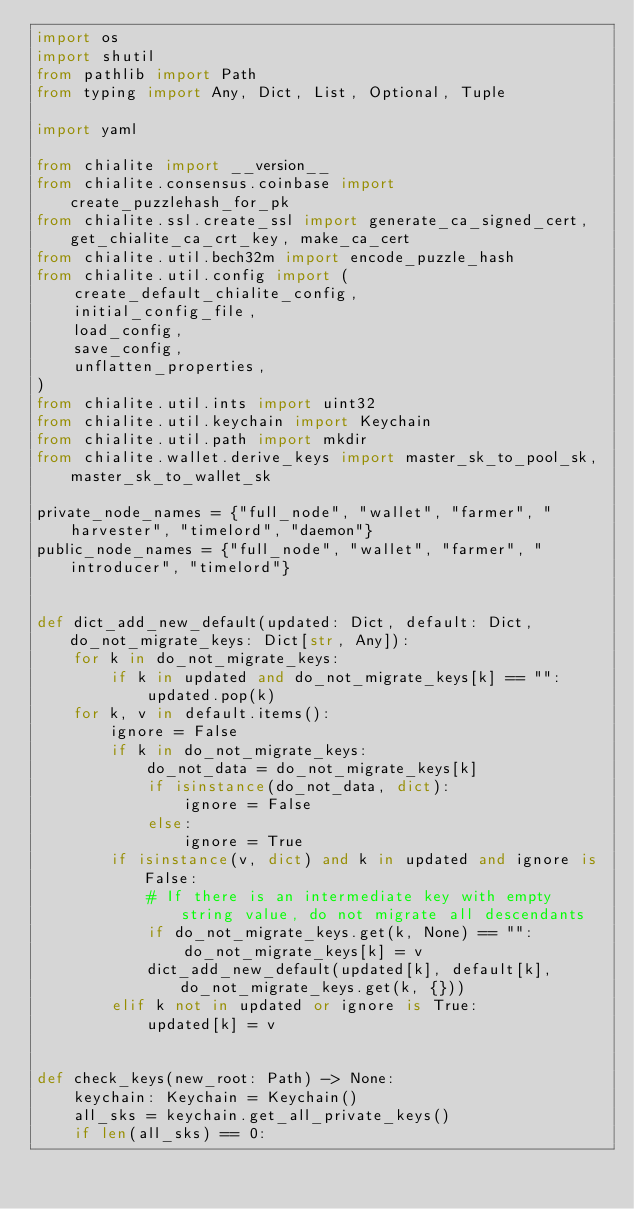<code> <loc_0><loc_0><loc_500><loc_500><_Python_>import os
import shutil
from pathlib import Path
from typing import Any, Dict, List, Optional, Tuple

import yaml

from chialite import __version__
from chialite.consensus.coinbase import create_puzzlehash_for_pk
from chialite.ssl.create_ssl import generate_ca_signed_cert, get_chialite_ca_crt_key, make_ca_cert
from chialite.util.bech32m import encode_puzzle_hash
from chialite.util.config import (
    create_default_chialite_config,
    initial_config_file,
    load_config,
    save_config,
    unflatten_properties,
)
from chialite.util.ints import uint32
from chialite.util.keychain import Keychain
from chialite.util.path import mkdir
from chialite.wallet.derive_keys import master_sk_to_pool_sk, master_sk_to_wallet_sk

private_node_names = {"full_node", "wallet", "farmer", "harvester", "timelord", "daemon"}
public_node_names = {"full_node", "wallet", "farmer", "introducer", "timelord"}


def dict_add_new_default(updated: Dict, default: Dict, do_not_migrate_keys: Dict[str, Any]):
    for k in do_not_migrate_keys:
        if k in updated and do_not_migrate_keys[k] == "":
            updated.pop(k)
    for k, v in default.items():
        ignore = False
        if k in do_not_migrate_keys:
            do_not_data = do_not_migrate_keys[k]
            if isinstance(do_not_data, dict):
                ignore = False
            else:
                ignore = True
        if isinstance(v, dict) and k in updated and ignore is False:
            # If there is an intermediate key with empty string value, do not migrate all descendants
            if do_not_migrate_keys.get(k, None) == "":
                do_not_migrate_keys[k] = v
            dict_add_new_default(updated[k], default[k], do_not_migrate_keys.get(k, {}))
        elif k not in updated or ignore is True:
            updated[k] = v


def check_keys(new_root: Path) -> None:
    keychain: Keychain = Keychain()
    all_sks = keychain.get_all_private_keys()
    if len(all_sks) == 0:</code> 